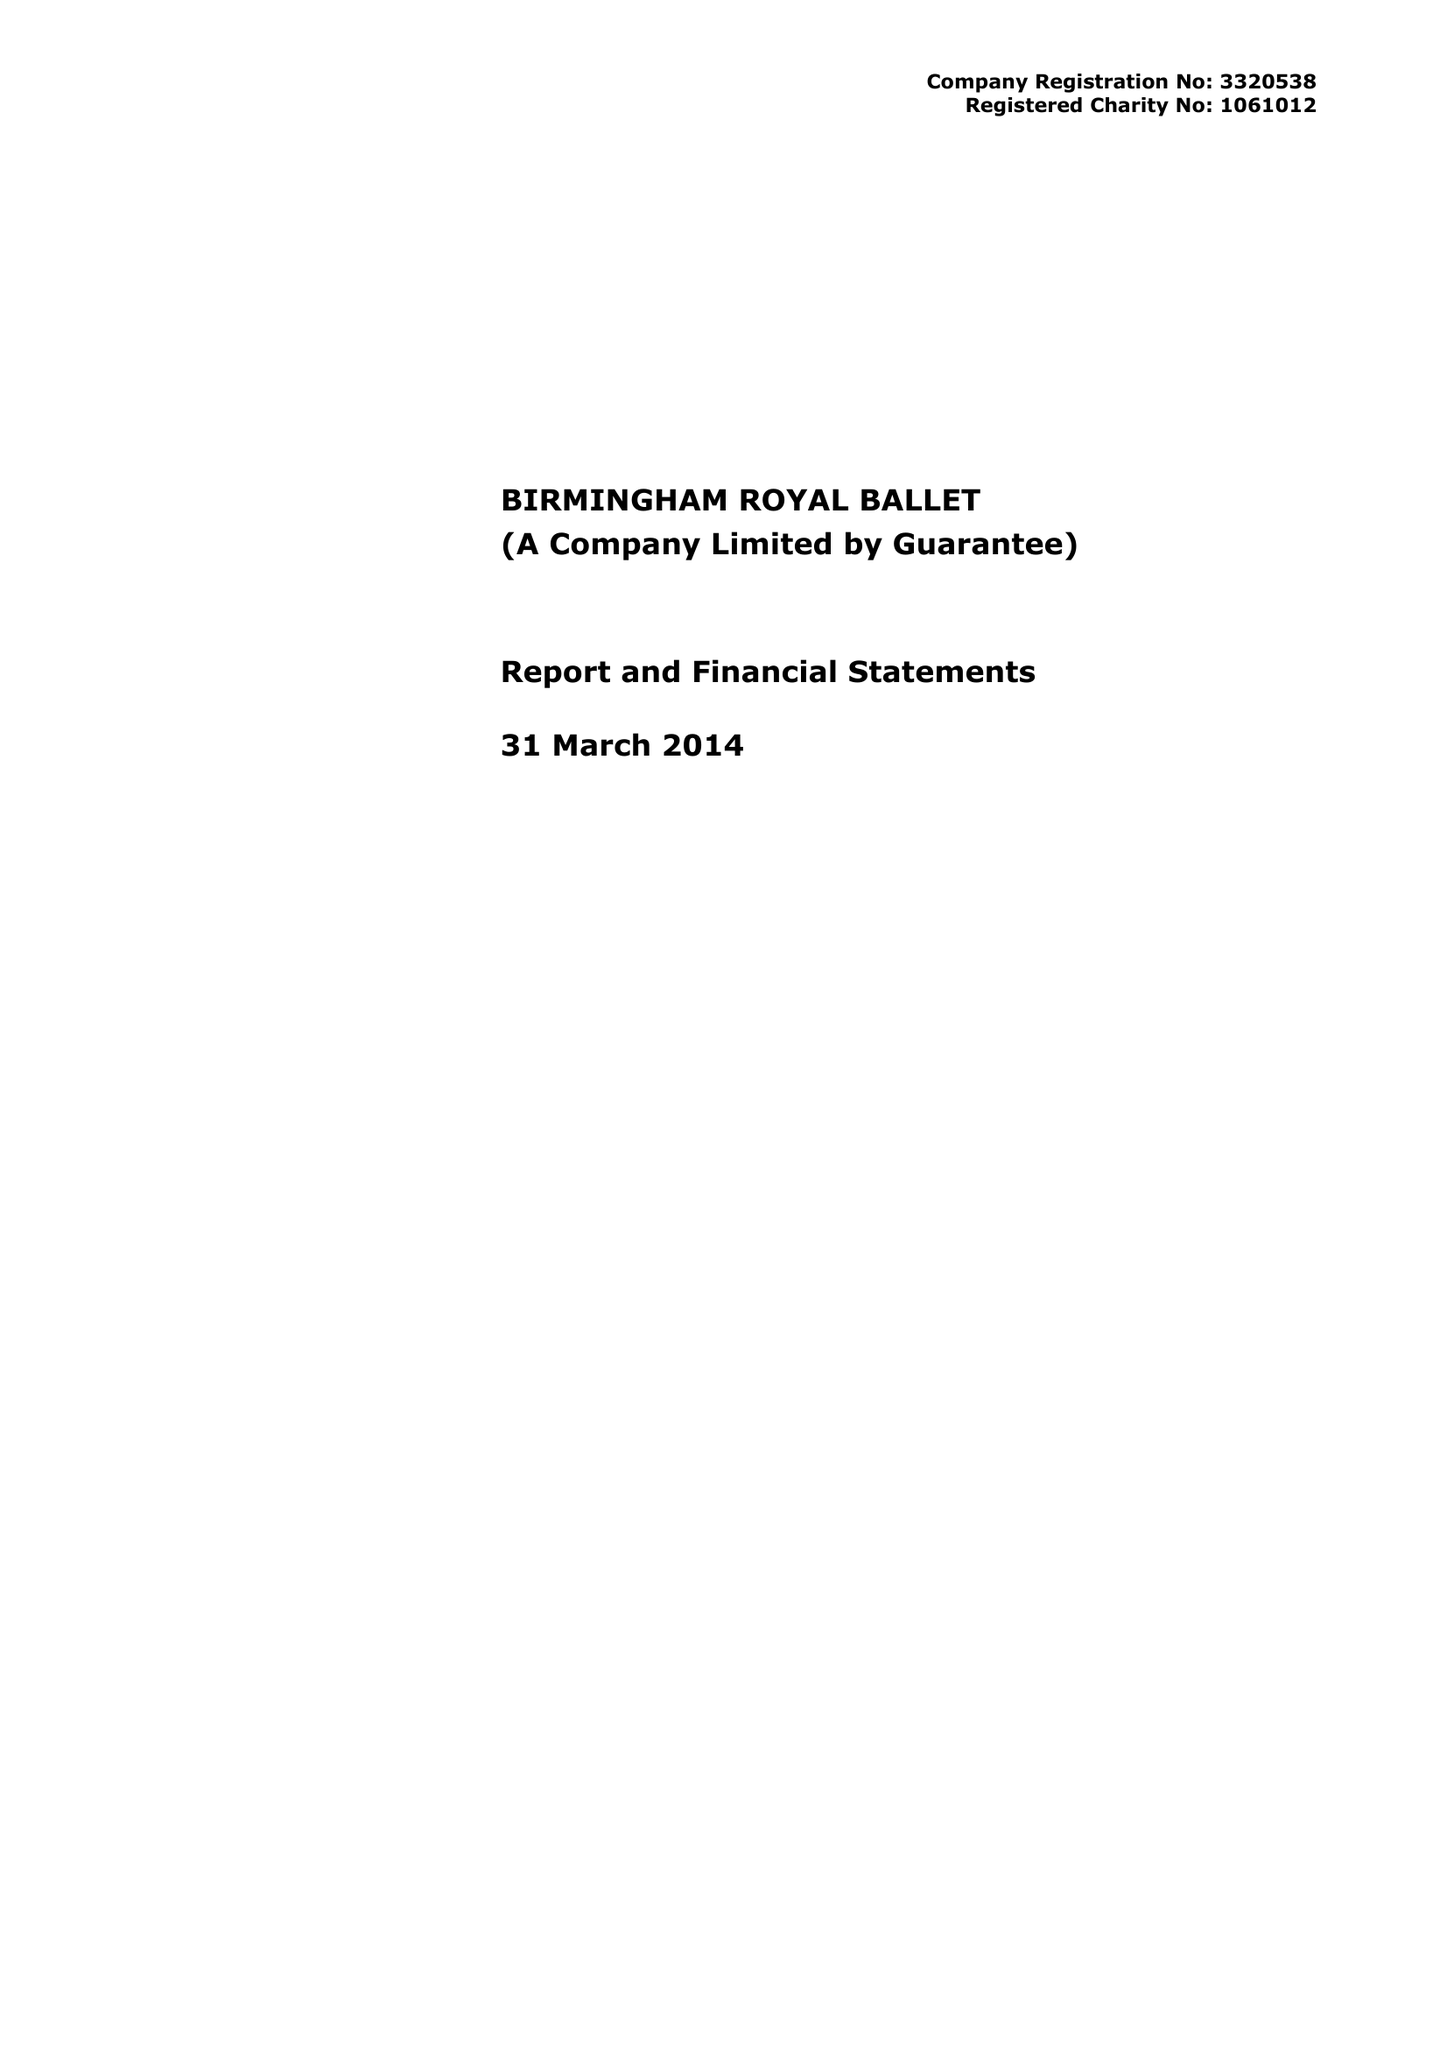What is the value for the charity_name?
Answer the question using a single word or phrase. Birmingham Royal Ballet 